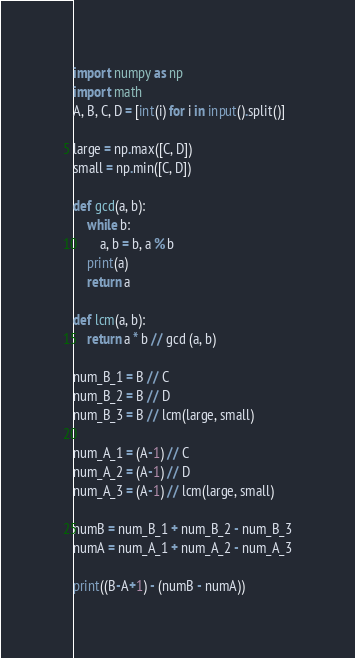Convert code to text. <code><loc_0><loc_0><loc_500><loc_500><_Python_>import numpy as np
import math
A, B, C, D = [int(i) for i in input().split()]
 
large = np.max([C, D])
small = np.min([C, D])
 
def gcd(a, b):
    while b:
        a, b = b, a % b
    print(a)
    return a
 
def lcm(a, b):
    return a * b // gcd (a, b)
 
num_B_1 = B // C
num_B_2 = B // D
num_B_3 = B // lcm(large, small)
 
num_A_1 = (A-1) // C
num_A_2 = (A-1) // D
num_A_3 = (A-1) // lcm(large, small)
 
numB = num_B_1 + num_B_2 - num_B_3
numA = num_A_1 + num_A_2 - num_A_3
 
print((B-A+1) - (numB - numA))
</code> 